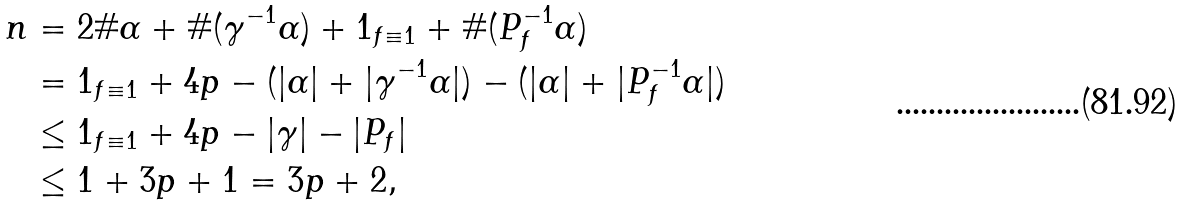Convert formula to latex. <formula><loc_0><loc_0><loc_500><loc_500>n & = 2 \# \alpha + \# ( \gamma ^ { - 1 } \alpha ) + { 1 } _ { f \equiv 1 } + \# ( P _ { f } ^ { - 1 } \alpha ) \\ & = { 1 } _ { f \equiv 1 } + 4 p - ( | \alpha | + | \gamma ^ { - 1 } \alpha | ) - ( | \alpha | + | P _ { f } ^ { - 1 } \alpha | ) \\ & \leq { 1 } _ { f \equiv 1 } + 4 p - | \gamma | - | P _ { f } | \\ & \leq 1 + 3 p + 1 = 3 p + 2 ,</formula> 